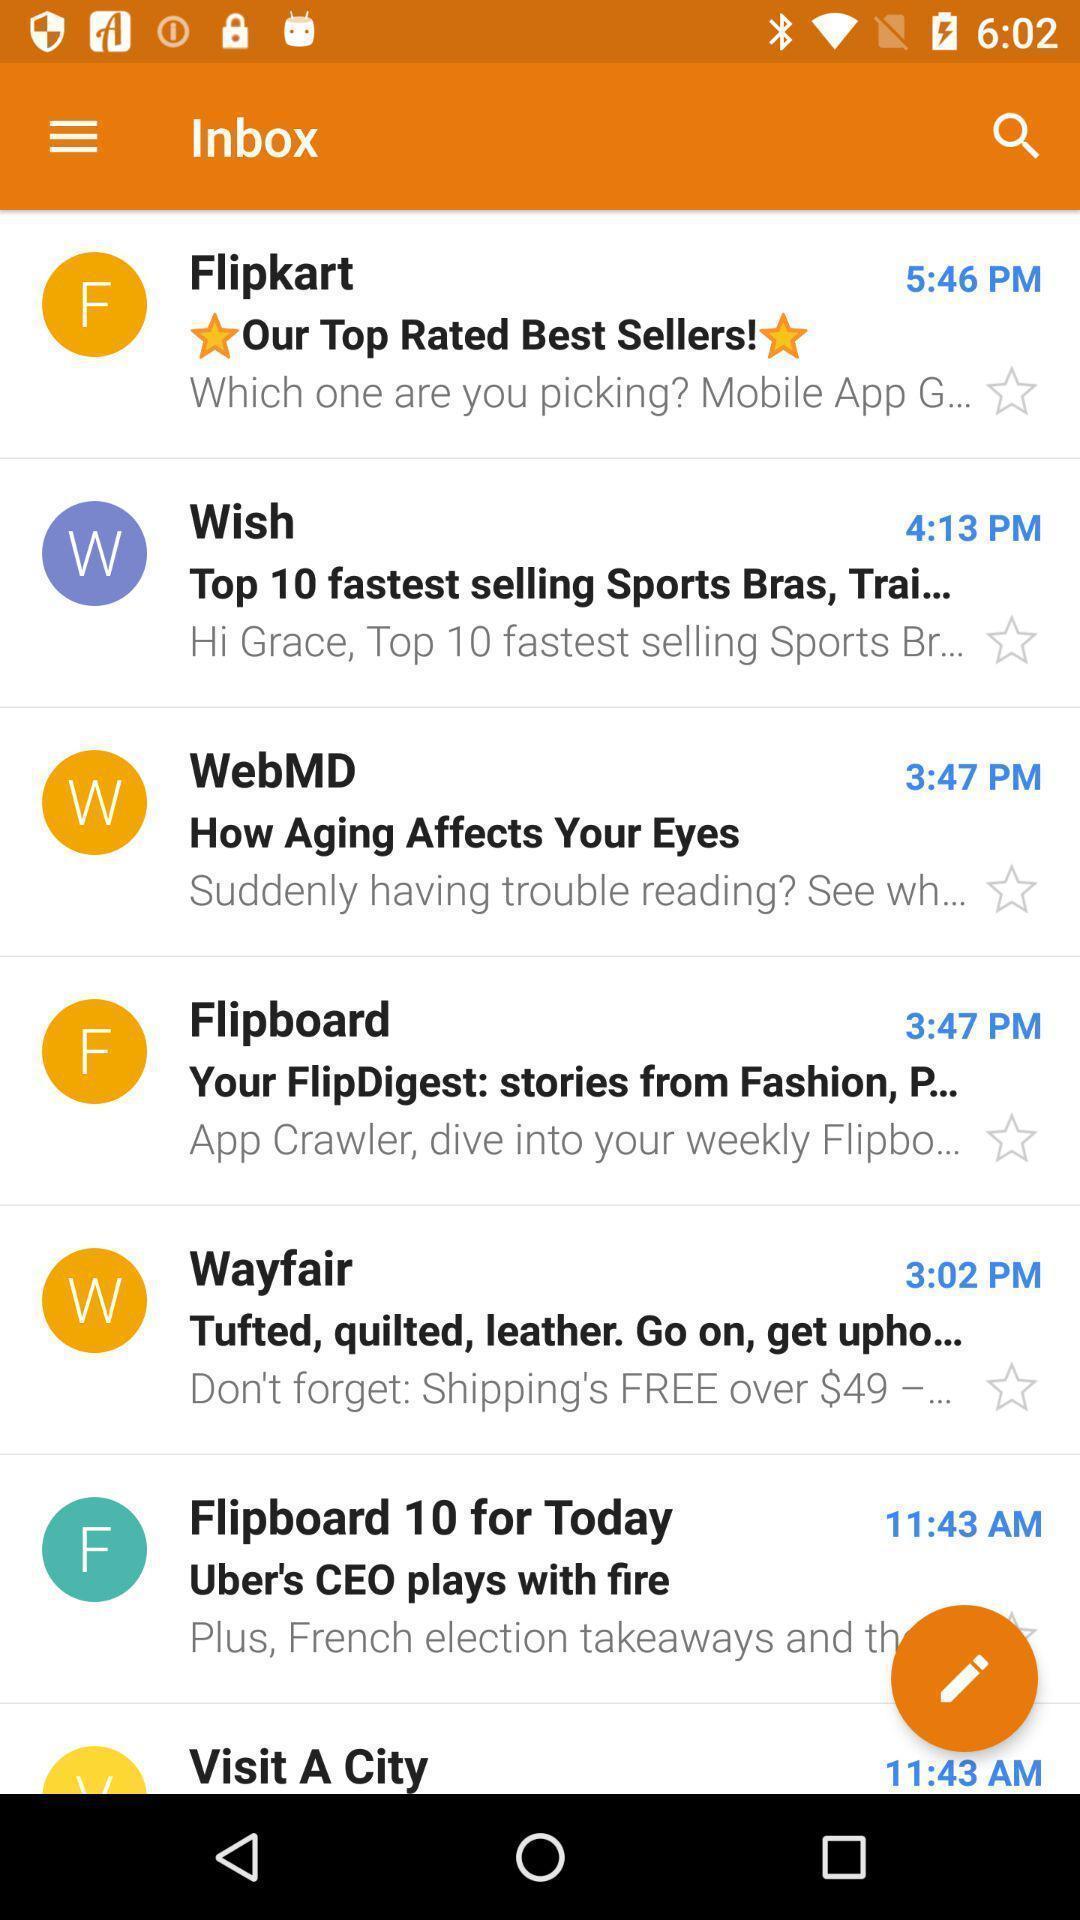Provide a textual representation of this image. Page displaying inbox of messages in an social application. 